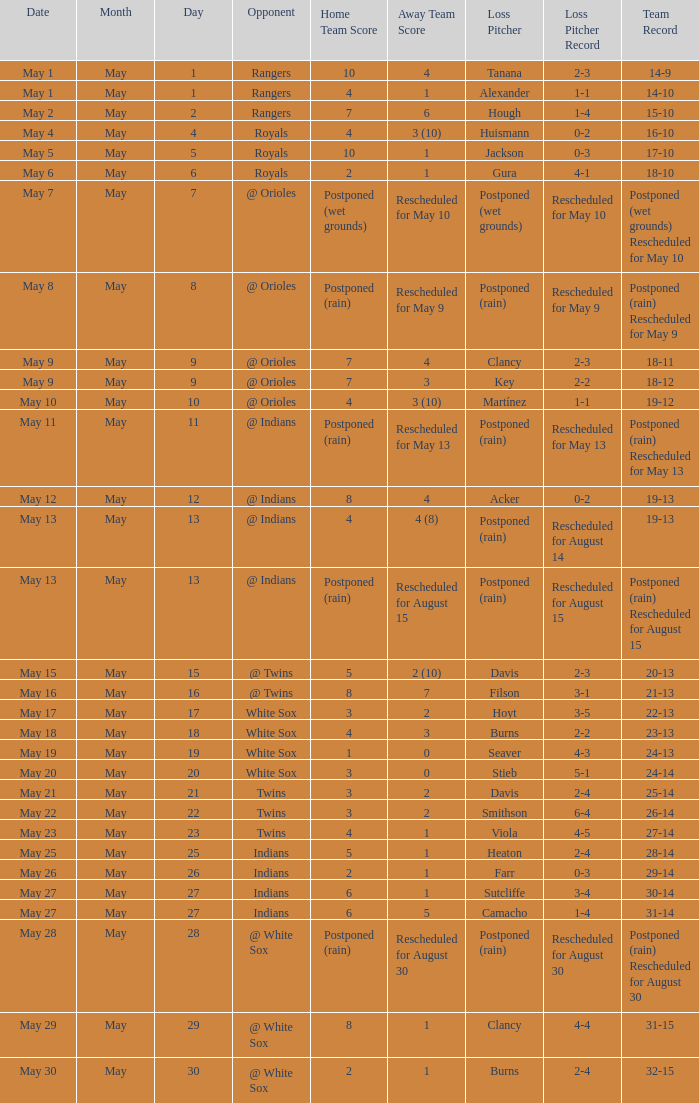What was the loss of the game when the record was 21-13? Filson (3-1). 